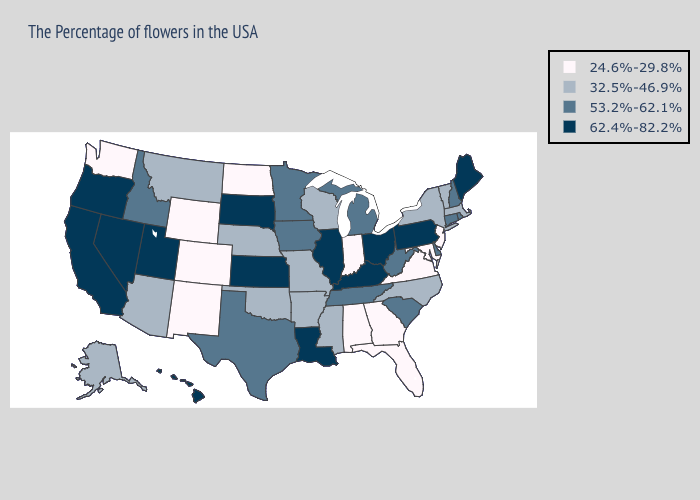What is the value of Oregon?
Quick response, please. 62.4%-82.2%. What is the highest value in the West ?
Concise answer only. 62.4%-82.2%. Name the states that have a value in the range 53.2%-62.1%?
Concise answer only. Rhode Island, New Hampshire, Connecticut, Delaware, South Carolina, West Virginia, Michigan, Tennessee, Minnesota, Iowa, Texas, Idaho. Name the states that have a value in the range 24.6%-29.8%?
Short answer required. New Jersey, Maryland, Virginia, Florida, Georgia, Indiana, Alabama, North Dakota, Wyoming, Colorado, New Mexico, Washington. Does Missouri have the highest value in the MidWest?
Be succinct. No. What is the lowest value in the West?
Keep it brief. 24.6%-29.8%. Name the states that have a value in the range 32.5%-46.9%?
Give a very brief answer. Massachusetts, Vermont, New York, North Carolina, Wisconsin, Mississippi, Missouri, Arkansas, Nebraska, Oklahoma, Montana, Arizona, Alaska. Which states have the lowest value in the MidWest?
Be succinct. Indiana, North Dakota. Name the states that have a value in the range 24.6%-29.8%?
Write a very short answer. New Jersey, Maryland, Virginia, Florida, Georgia, Indiana, Alabama, North Dakota, Wyoming, Colorado, New Mexico, Washington. What is the value of Maine?
Keep it brief. 62.4%-82.2%. Name the states that have a value in the range 24.6%-29.8%?
Be succinct. New Jersey, Maryland, Virginia, Florida, Georgia, Indiana, Alabama, North Dakota, Wyoming, Colorado, New Mexico, Washington. What is the value of Missouri?
Concise answer only. 32.5%-46.9%. Is the legend a continuous bar?
Answer briefly. No. 